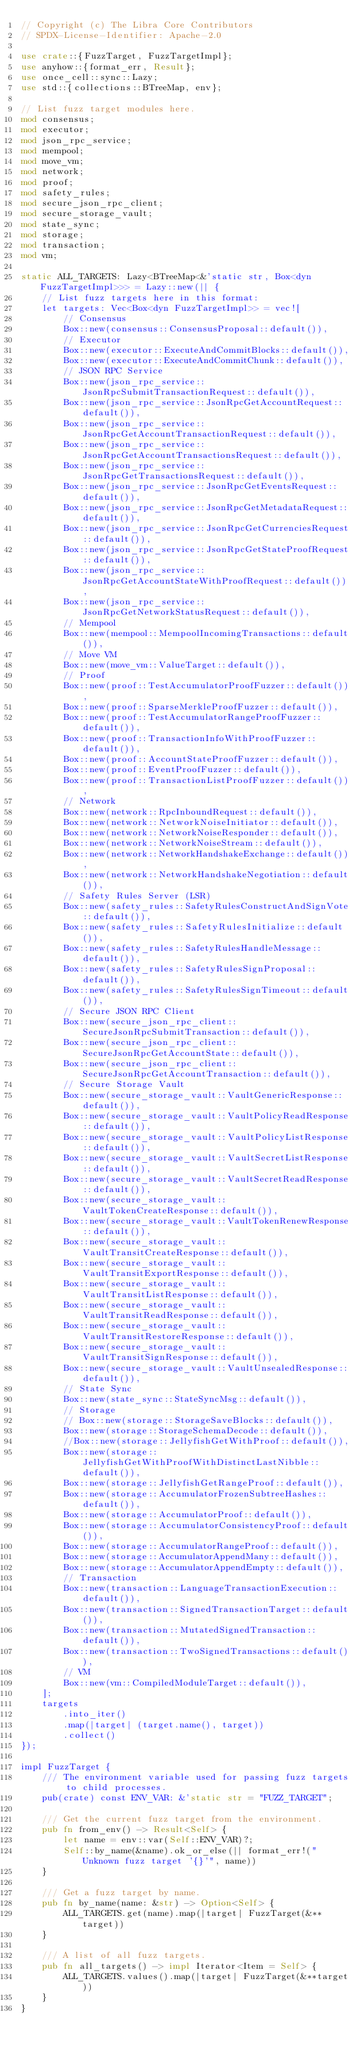<code> <loc_0><loc_0><loc_500><loc_500><_Rust_>// Copyright (c) The Libra Core Contributors
// SPDX-License-Identifier: Apache-2.0

use crate::{FuzzTarget, FuzzTargetImpl};
use anyhow::{format_err, Result};
use once_cell::sync::Lazy;
use std::{collections::BTreeMap, env};

// List fuzz target modules here.
mod consensus;
mod executor;
mod json_rpc_service;
mod mempool;
mod move_vm;
mod network;
mod proof;
mod safety_rules;
mod secure_json_rpc_client;
mod secure_storage_vault;
mod state_sync;
mod storage;
mod transaction;
mod vm;

static ALL_TARGETS: Lazy<BTreeMap<&'static str, Box<dyn FuzzTargetImpl>>> = Lazy::new(|| {
    // List fuzz targets here in this format:
    let targets: Vec<Box<dyn FuzzTargetImpl>> = vec![
        // Consensus
        Box::new(consensus::ConsensusProposal::default()),
        // Executor
        Box::new(executor::ExecuteAndCommitBlocks::default()),
        Box::new(executor::ExecuteAndCommitChunk::default()),
        // JSON RPC Service
        Box::new(json_rpc_service::JsonRpcSubmitTransactionRequest::default()),
        Box::new(json_rpc_service::JsonRpcGetAccountRequest::default()),
        Box::new(json_rpc_service::JsonRpcGetAccountTransactionRequest::default()),
        Box::new(json_rpc_service::JsonRpcGetAccountTransactionsRequest::default()),
        Box::new(json_rpc_service::JsonRpcGetTransactionsRequest::default()),
        Box::new(json_rpc_service::JsonRpcGetEventsRequest::default()),
        Box::new(json_rpc_service::JsonRpcGetMetadataRequest::default()),
        Box::new(json_rpc_service::JsonRpcGetCurrenciesRequest::default()),
        Box::new(json_rpc_service::JsonRpcGetStateProofRequest::default()),
        Box::new(json_rpc_service::JsonRpcGetAccountStateWithProofRequest::default()),
        Box::new(json_rpc_service::JsonRpcGetNetworkStatusRequest::default()),
        // Mempool
        Box::new(mempool::MempoolIncomingTransactions::default()),
        // Move VM
        Box::new(move_vm::ValueTarget::default()),
        // Proof
        Box::new(proof::TestAccumulatorProofFuzzer::default()),
        Box::new(proof::SparseMerkleProofFuzzer::default()),
        Box::new(proof::TestAccumulatorRangeProofFuzzer::default()),
        Box::new(proof::TransactionInfoWithProofFuzzer::default()),
        Box::new(proof::AccountStateProofFuzzer::default()),
        Box::new(proof::EventProofFuzzer::default()),
        Box::new(proof::TransactionListProofFuzzer::default()),
        // Network
        Box::new(network::RpcInboundRequest::default()),
        Box::new(network::NetworkNoiseInitiator::default()),
        Box::new(network::NetworkNoiseResponder::default()),
        Box::new(network::NetworkNoiseStream::default()),
        Box::new(network::NetworkHandshakeExchange::default()),
        Box::new(network::NetworkHandshakeNegotiation::default()),
        // Safety Rules Server (LSR)
        Box::new(safety_rules::SafetyRulesConstructAndSignVote::default()),
        Box::new(safety_rules::SafetyRulesInitialize::default()),
        Box::new(safety_rules::SafetyRulesHandleMessage::default()),
        Box::new(safety_rules::SafetyRulesSignProposal::default()),
        Box::new(safety_rules::SafetyRulesSignTimeout::default()),
        // Secure JSON RPC Client
        Box::new(secure_json_rpc_client::SecureJsonRpcSubmitTransaction::default()),
        Box::new(secure_json_rpc_client::SecureJsonRpcGetAccountState::default()),
        Box::new(secure_json_rpc_client::SecureJsonRpcGetAccountTransaction::default()),
        // Secure Storage Vault
        Box::new(secure_storage_vault::VaultGenericResponse::default()),
        Box::new(secure_storage_vault::VaultPolicyReadResponse::default()),
        Box::new(secure_storage_vault::VaultPolicyListResponse::default()),
        Box::new(secure_storage_vault::VaultSecretListResponse::default()),
        Box::new(secure_storage_vault::VaultSecretReadResponse::default()),
        Box::new(secure_storage_vault::VaultTokenCreateResponse::default()),
        Box::new(secure_storage_vault::VaultTokenRenewResponse::default()),
        Box::new(secure_storage_vault::VaultTransitCreateResponse::default()),
        Box::new(secure_storage_vault::VaultTransitExportResponse::default()),
        Box::new(secure_storage_vault::VaultTransitListResponse::default()),
        Box::new(secure_storage_vault::VaultTransitReadResponse::default()),
        Box::new(secure_storage_vault::VaultTransitRestoreResponse::default()),
        Box::new(secure_storage_vault::VaultTransitSignResponse::default()),
        Box::new(secure_storage_vault::VaultUnsealedResponse::default()),
        // State Sync
        Box::new(state_sync::StateSyncMsg::default()),
        // Storage
        // Box::new(storage::StorageSaveBlocks::default()),
        Box::new(storage::StorageSchemaDecode::default()),
        //Box::new(storage::JellyfishGetWithProof::default()),
        Box::new(storage::JellyfishGetWithProofWithDistinctLastNibble::default()),
        Box::new(storage::JellyfishGetRangeProof::default()),
        Box::new(storage::AccumulatorFrozenSubtreeHashes::default()),
        Box::new(storage::AccumulatorProof::default()),
        Box::new(storage::AccumulatorConsistencyProof::default()),
        Box::new(storage::AccumulatorRangeProof::default()),
        Box::new(storage::AccumulatorAppendMany::default()),
        Box::new(storage::AccumulatorAppendEmpty::default()),
        // Transaction
        Box::new(transaction::LanguageTransactionExecution::default()),
        Box::new(transaction::SignedTransactionTarget::default()),
        Box::new(transaction::MutatedSignedTransaction::default()),
        Box::new(transaction::TwoSignedTransactions::default()),
        // VM
        Box::new(vm::CompiledModuleTarget::default()),
    ];
    targets
        .into_iter()
        .map(|target| (target.name(), target))
        .collect()
});

impl FuzzTarget {
    /// The environment variable used for passing fuzz targets to child processes.
    pub(crate) const ENV_VAR: &'static str = "FUZZ_TARGET";

    /// Get the current fuzz target from the environment.
    pub fn from_env() -> Result<Self> {
        let name = env::var(Self::ENV_VAR)?;
        Self::by_name(&name).ok_or_else(|| format_err!("Unknown fuzz target '{}'", name))
    }

    /// Get a fuzz target by name.
    pub fn by_name(name: &str) -> Option<Self> {
        ALL_TARGETS.get(name).map(|target| FuzzTarget(&**target))
    }

    /// A list of all fuzz targets.
    pub fn all_targets() -> impl Iterator<Item = Self> {
        ALL_TARGETS.values().map(|target| FuzzTarget(&**target))
    }
}
</code> 